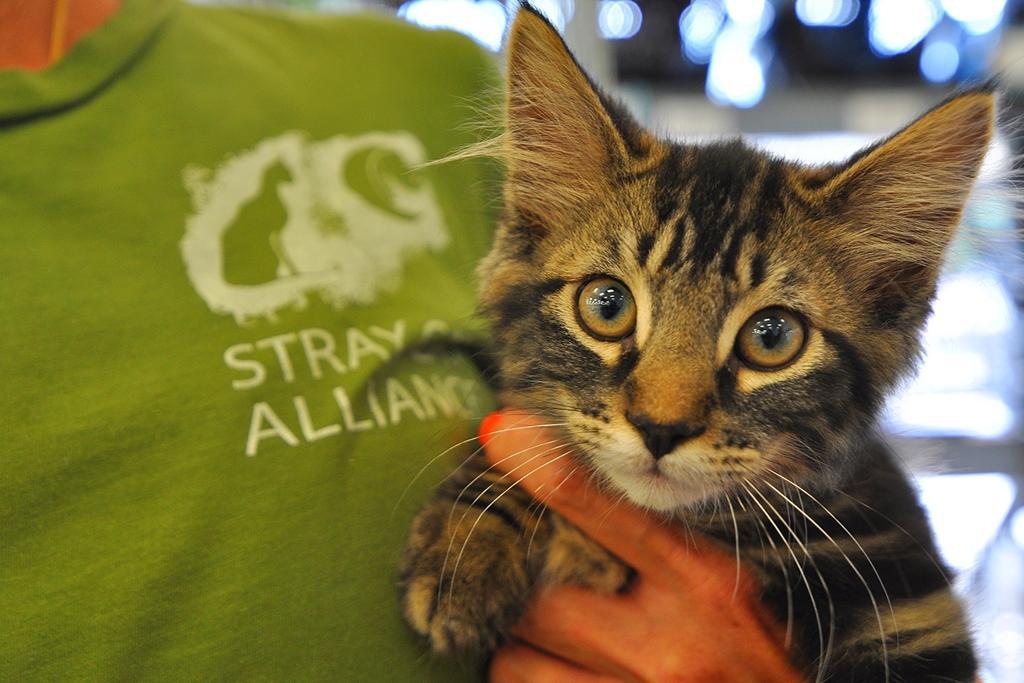Can you describe this image briefly? There is a person wearing a green t shirt with something written on that. Also there is a logo. And the person is holding a cat. In the background it is blurred. 